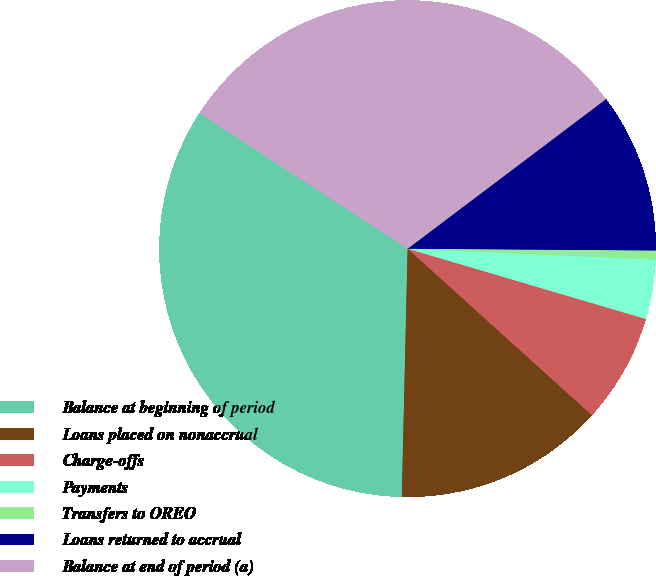Convert chart. <chart><loc_0><loc_0><loc_500><loc_500><pie_chart><fcel>Balance at beginning of period<fcel>Loans placed on nonaccrual<fcel>Charge-offs<fcel>Payments<fcel>Transfers to OREO<fcel>Loans returned to accrual<fcel>Balance at end of period (a)<nl><fcel>33.81%<fcel>13.68%<fcel>7.13%<fcel>3.86%<fcel>0.59%<fcel>10.4%<fcel>30.54%<nl></chart> 